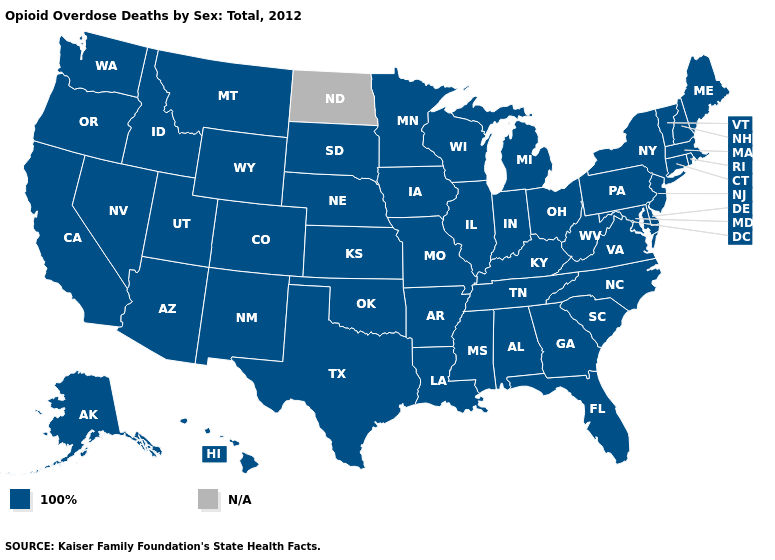What is the value of Alaska?
Answer briefly. 100%. What is the value of Kentucky?
Write a very short answer. 100%. What is the lowest value in the West?
Quick response, please. 100%. Among the states that border Virginia , which have the lowest value?
Short answer required. Kentucky, Maryland, North Carolina, Tennessee, West Virginia. Among the states that border West Virginia , which have the lowest value?
Quick response, please. Kentucky, Maryland, Ohio, Pennsylvania, Virginia. What is the value of Nebraska?
Write a very short answer. 100%. Name the states that have a value in the range 100%?
Answer briefly. Alabama, Alaska, Arizona, Arkansas, California, Colorado, Connecticut, Delaware, Florida, Georgia, Hawaii, Idaho, Illinois, Indiana, Iowa, Kansas, Kentucky, Louisiana, Maine, Maryland, Massachusetts, Michigan, Minnesota, Mississippi, Missouri, Montana, Nebraska, Nevada, New Hampshire, New Jersey, New Mexico, New York, North Carolina, Ohio, Oklahoma, Oregon, Pennsylvania, Rhode Island, South Carolina, South Dakota, Tennessee, Texas, Utah, Vermont, Virginia, Washington, West Virginia, Wisconsin, Wyoming. Among the states that border North Carolina , which have the lowest value?
Keep it brief. Georgia, South Carolina, Tennessee, Virginia. Among the states that border California , which have the highest value?
Give a very brief answer. Arizona, Nevada, Oregon. What is the highest value in states that border Kentucky?
Give a very brief answer. 100%. What is the lowest value in the Northeast?
Quick response, please. 100%. What is the value of South Dakota?
Give a very brief answer. 100%. Among the states that border New Hampshire , which have the highest value?
Keep it brief. Maine, Massachusetts, Vermont. 